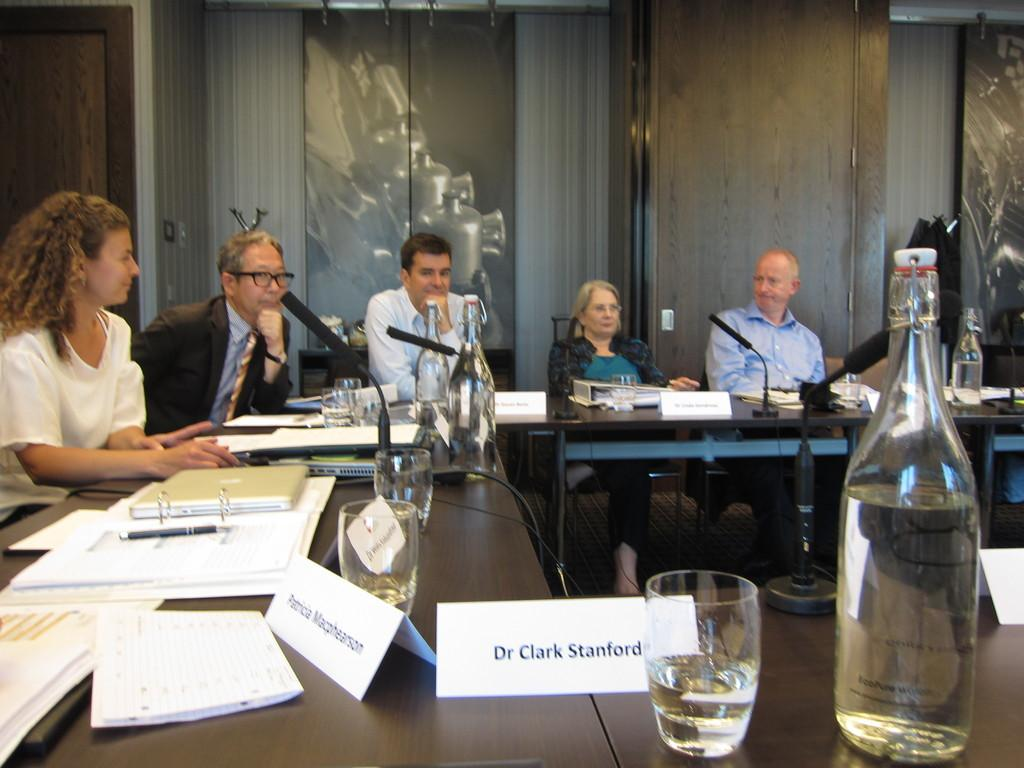<image>
Render a clear and concise summary of the photo. A place setting for Dr Clark Stanford is at a table filled with people. 